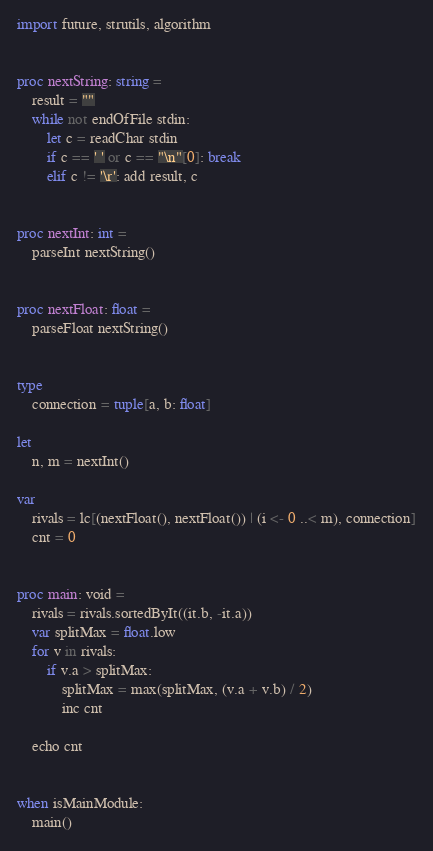Convert code to text. <code><loc_0><loc_0><loc_500><loc_500><_Nim_>import future, strutils, algorithm


proc nextString: string =
    result = ""
    while not endOfFile stdin:
        let c = readChar stdin
        if c == ' ' or c == "\n"[0]: break
        elif c != '\r': add result, c


proc nextInt: int =
    parseInt nextString()


proc nextFloat: float =
    parseFloat nextString()


type
    connection = tuple[a, b: float]

let
    n, m = nextInt()

var
    rivals = lc[(nextFloat(), nextFloat()) | (i <- 0 ..< m), connection]
    cnt = 0


proc main: void =
    rivals = rivals.sortedByIt((it.b, -it.a))
    var splitMax = float.low
    for v in rivals:
        if v.a > splitMax:
            splitMax = max(splitMax, (v.a + v.b) / 2)
            inc cnt

    echo cnt


when isMainModule:
    main()
</code> 